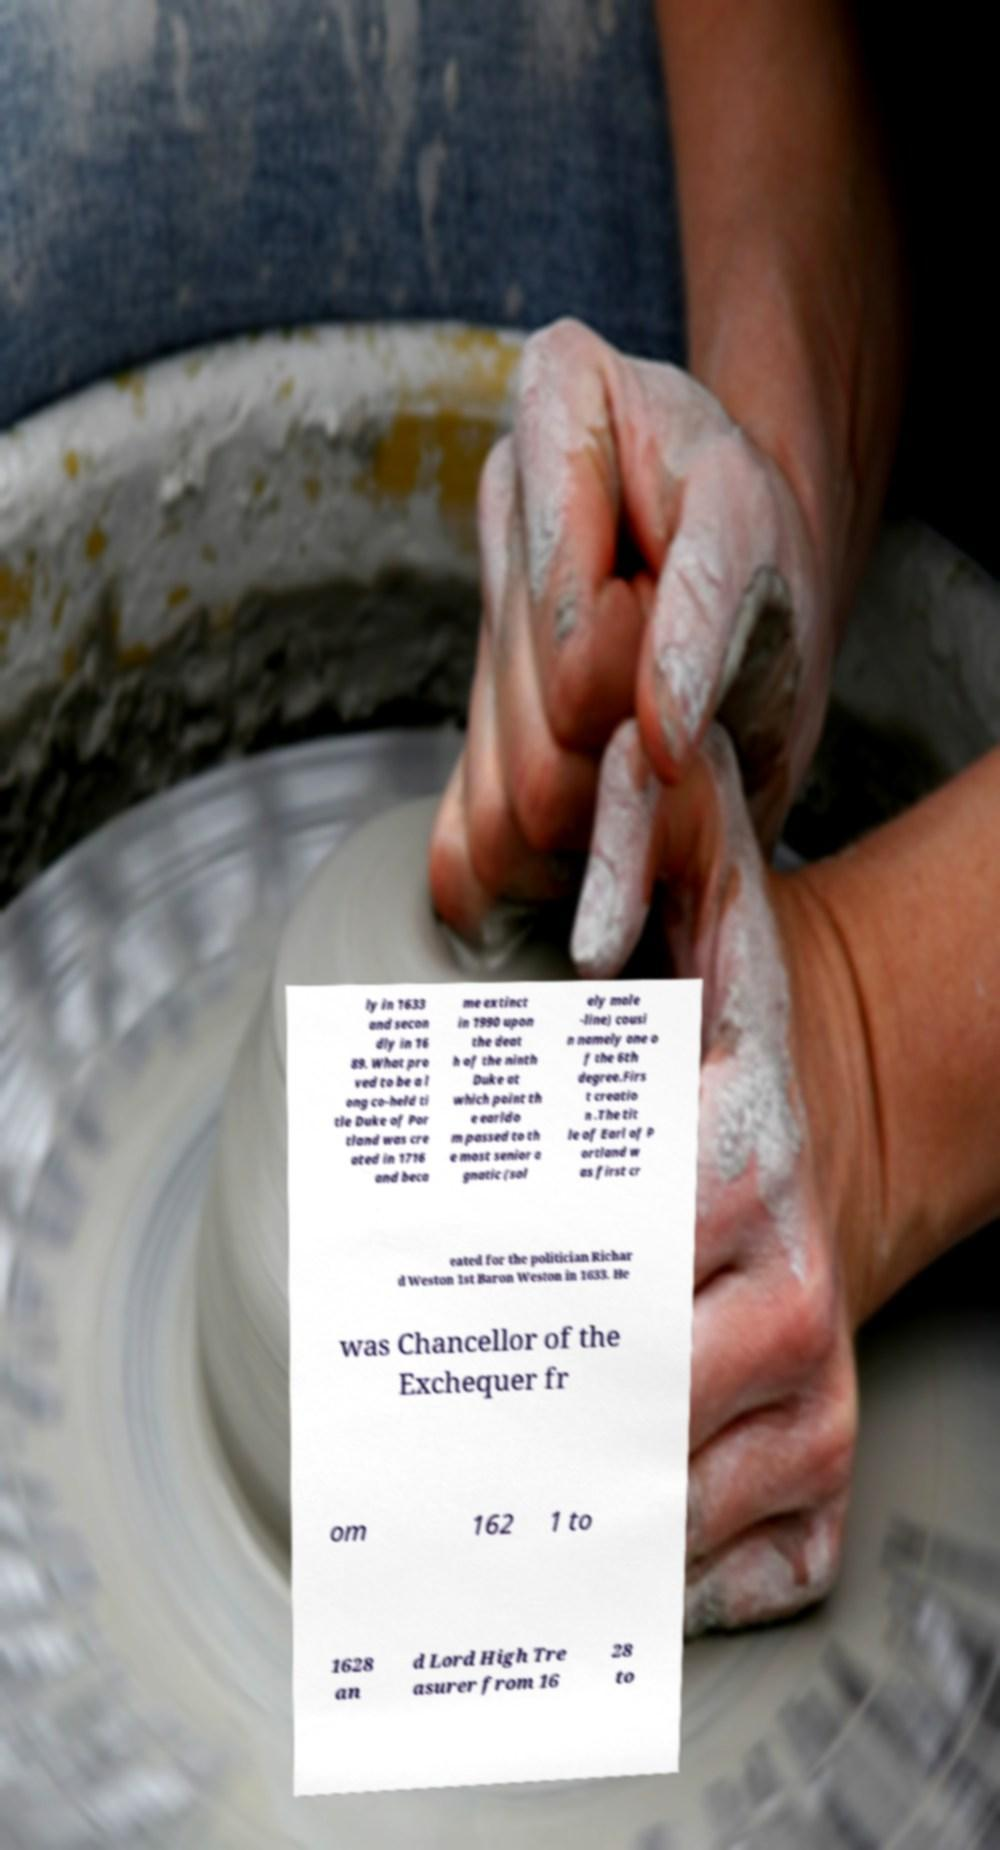For documentation purposes, I need the text within this image transcribed. Could you provide that? ly in 1633 and secon dly in 16 89. What pro ved to be a l ong co-held ti tle Duke of Por tland was cre ated in 1716 and beca me extinct in 1990 upon the deat h of the ninth Duke at which point th e earldo m passed to th e most senior a gnatic (sol ely male -line) cousi n namely one o f the 6th degree.Firs t creatio n .The tit le of Earl of P ortland w as first cr eated for the politician Richar d Weston 1st Baron Weston in 1633. He was Chancellor of the Exchequer fr om 162 1 to 1628 an d Lord High Tre asurer from 16 28 to 